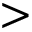Convert formula to latex. <formula><loc_0><loc_0><loc_500><loc_500>></formula> 